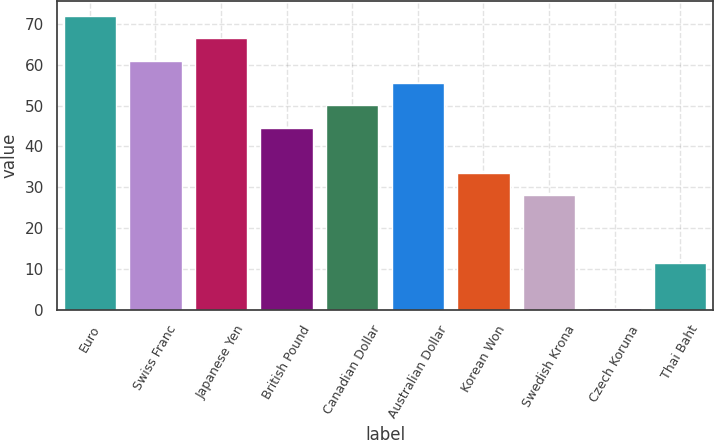<chart> <loc_0><loc_0><loc_500><loc_500><bar_chart><fcel>Euro<fcel>Swiss Franc<fcel>Japanese Yen<fcel>British Pound<fcel>Canadian Dollar<fcel>Australian Dollar<fcel>Korean Won<fcel>Swedish Krona<fcel>Czech Koruna<fcel>Thai Baht<nl><fcel>71.97<fcel>60.99<fcel>66.48<fcel>44.52<fcel>50.01<fcel>55.5<fcel>33.54<fcel>28.05<fcel>0.6<fcel>11.58<nl></chart> 